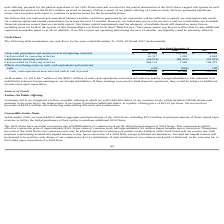According to Everbridge's financial document, How much cash, cash equivalents and restricted cash was held by foreign subsidiaries at December 31, 2019? $6.7 million of the $539.7 million of cash, cash equivalents and restricted cash. The document states: "At December 31, 2019, $6.7 million of the $539.7 million of cash, cash equivalents and restricted cash was held by foreign subsidiaries. Our intention..." Also, Where is foreign earnings reinvested? in our foreign subsidiaries.. The document states: "ntion is to indefinitely reinvest foreign earnings in our foreign subsidiaries. If these earnings were used to fund domestic operations, they would be..." Also, What would happen if earnings were used to fund domestic operations? subject to additional income taxes upon repatriation.. The document states: "re used to fund domestic operations, they would be subject to additional income taxes upon repatriation...." Also, can you calculate: What is the change in Cash, cash equivalents and restricted cash at beginning of period from December 31, 2019 to December 31, 2018? Based on the calculation: 60,068-103,051, the result is -42983 (in thousands). This is based on the information: "ents and restricted cash at beginning of period $ 60,068 $ 103,051 $ 60,765 restricted cash at beginning of period $ 60,068 $ 103,051 $ 60,765..." The key data points involved are: 103,051, 60,068. Also, can you calculate: What is the change in Cash provided by operating activities from December 31, 2019 to December 31, 2018? Based on the calculation: 10,317-3,295, the result is 7022 (in thousands). This is based on the information: "Cash provided by operating activities 10,317 3,295 4,863 Cash provided by operating activities 10,317 3,295 4,863..." The key data points involved are: 10,317, 3,295. Also, can you calculate: What is the change in Cash used in investing activities from December 31, 2019 to December 31, 2018? Based on the calculation: 24,574-48,413, the result is -23839 (in thousands). This is based on the information: "Cash used in investing activities (24,574) (48,413) (70,972) Cash used in investing activities (24,574) (48,413) (70,972)..." The key data points involved are: 24,574, 48,413. 